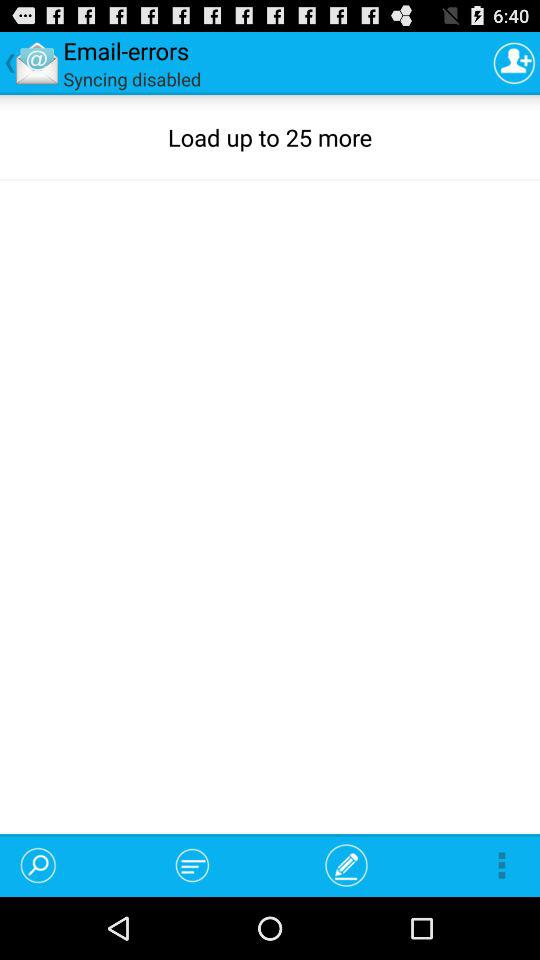How many more emails can be loaded?
Answer the question using a single word or phrase. 25 